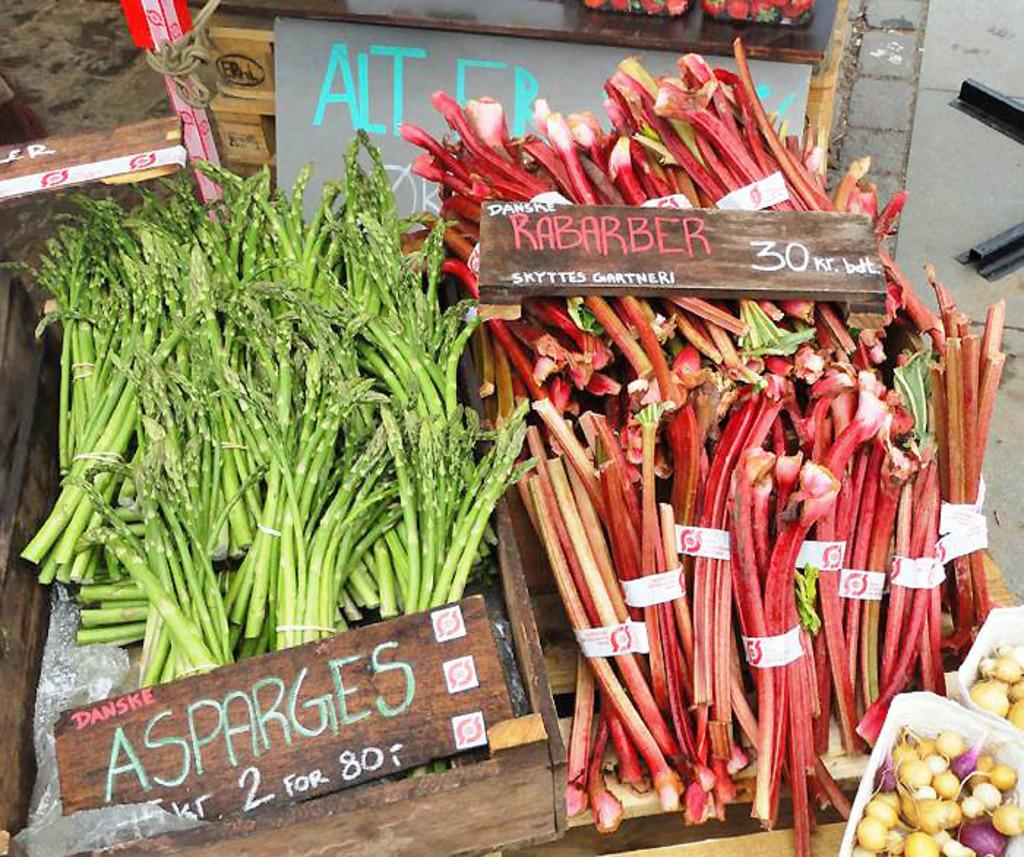What is the main object in the image? There is a wooden plank in the image. What is placed on the wooden plank? Leafy vegetables are present on the wooden plank. Are there any additional items related to the leafy vegetables? Price boards are associated with the leafy vegetables. How many girls are performing an action on the chair in the image? There are no girls or chairs present in the image. 